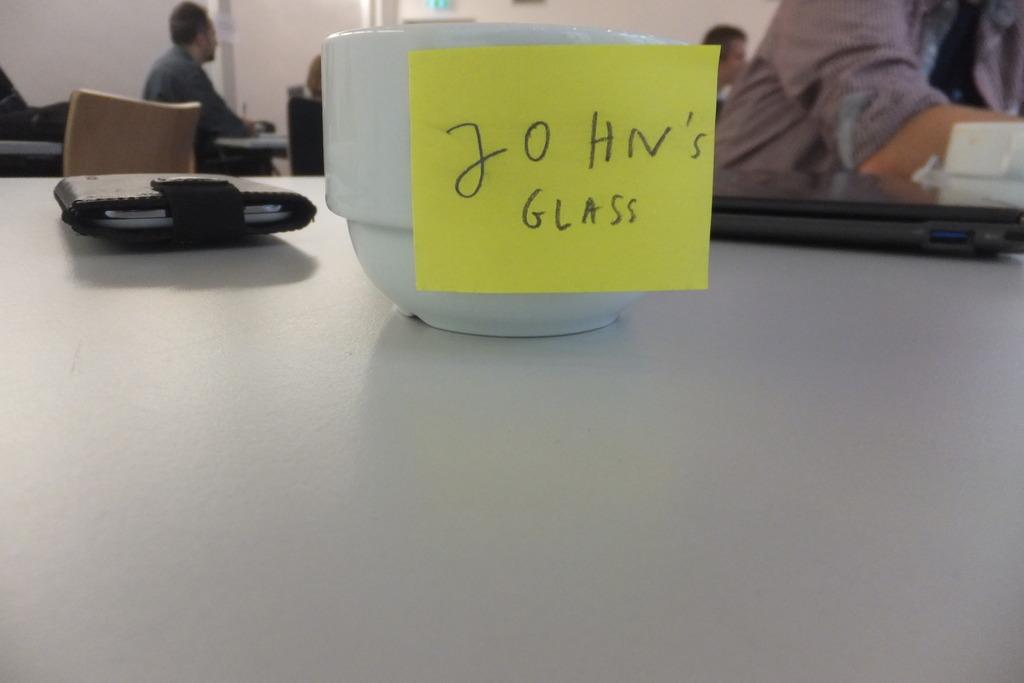What piece of furniture is visible in the image? There is a table in the image. What object can be seen on the table? A purse is present on the table. What else is on the table besides the purse? There is a bowl with a slip on the table. Can you describe the people in the background of the image? There are persons sitting in the background of the image. What type of sugar is being used by the judge in the image? There is no judge or sugar present in the image. What is the pail being used for in the image? There is no pail present in the image. 